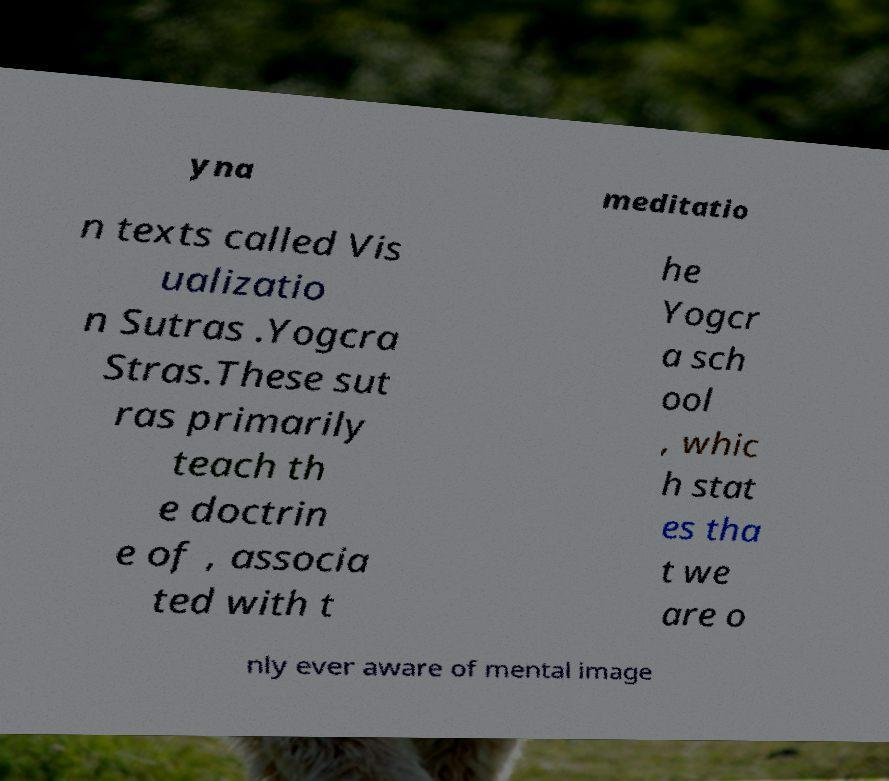Please read and relay the text visible in this image. What does it say? yna meditatio n texts called Vis ualizatio n Sutras .Yogcra Stras.These sut ras primarily teach th e doctrin e of , associa ted with t he Yogcr a sch ool , whic h stat es tha t we are o nly ever aware of mental image 